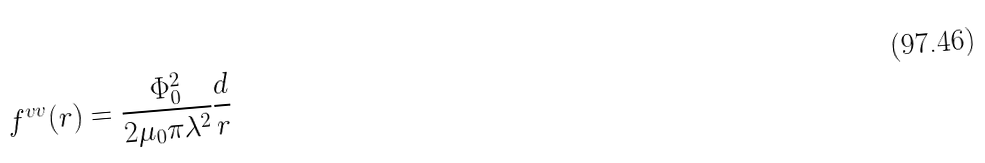Convert formula to latex. <formula><loc_0><loc_0><loc_500><loc_500>f ^ { v v } ( r ) = \frac { \Phi _ { 0 } ^ { 2 } } { 2 \mu _ { 0 } \pi \lambda ^ { 2 } } \frac { d } { r }</formula> 